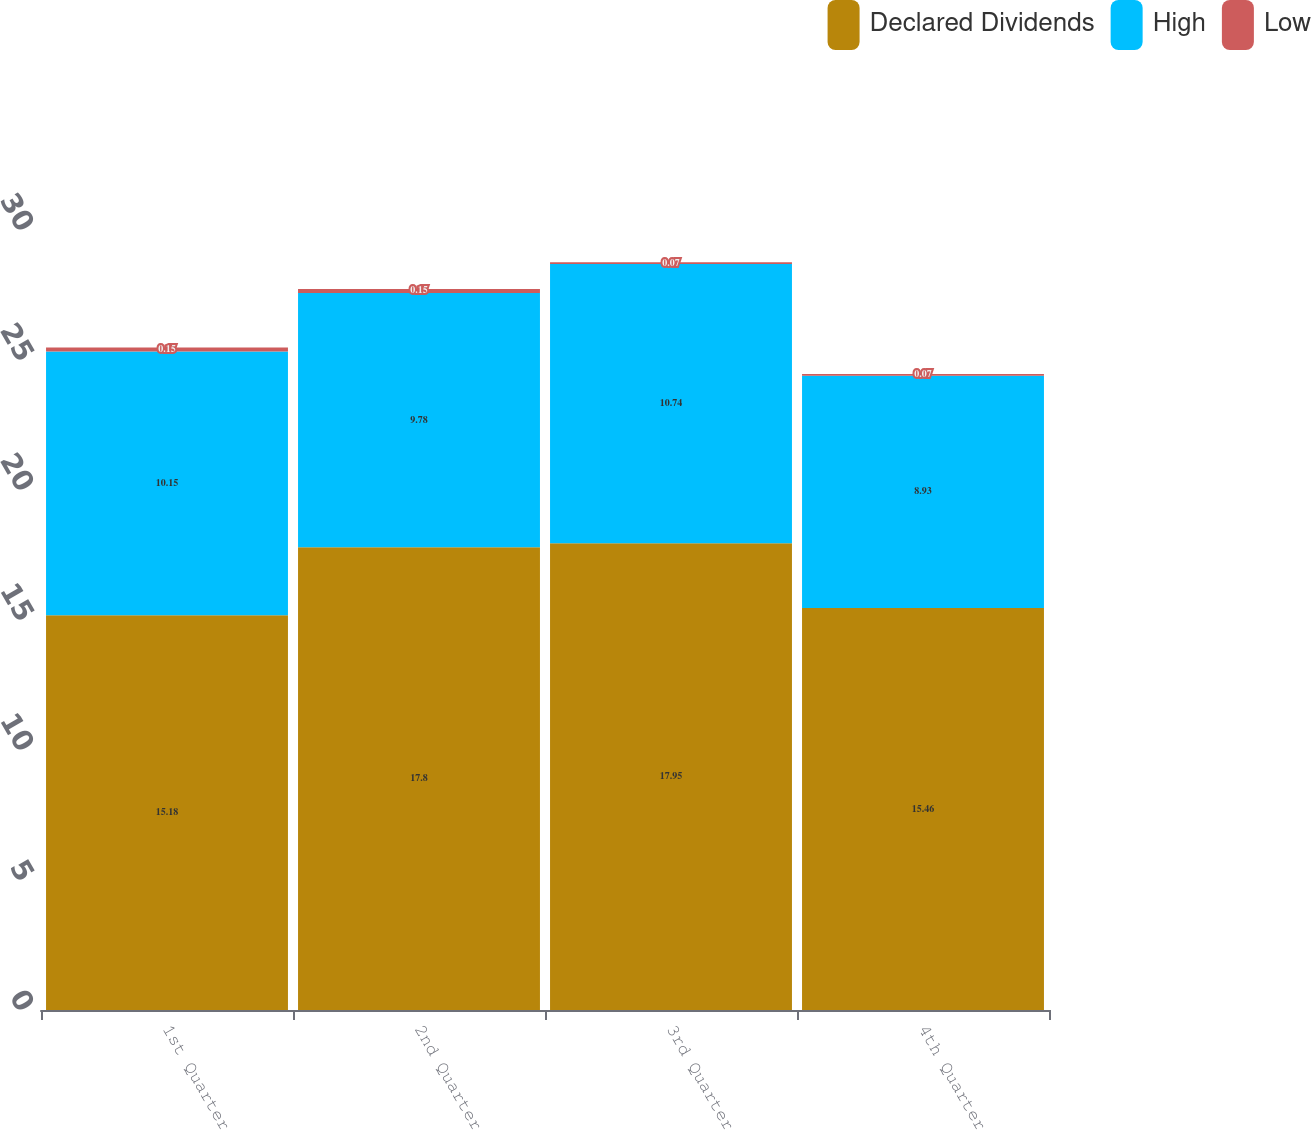Convert chart. <chart><loc_0><loc_0><loc_500><loc_500><stacked_bar_chart><ecel><fcel>1st Quarter<fcel>2nd Quarter<fcel>3rd Quarter<fcel>4th Quarter<nl><fcel>Declared Dividends<fcel>15.18<fcel>17.8<fcel>17.95<fcel>15.46<nl><fcel>High<fcel>10.15<fcel>9.78<fcel>10.74<fcel>8.93<nl><fcel>Low<fcel>0.15<fcel>0.15<fcel>0.07<fcel>0.07<nl></chart> 